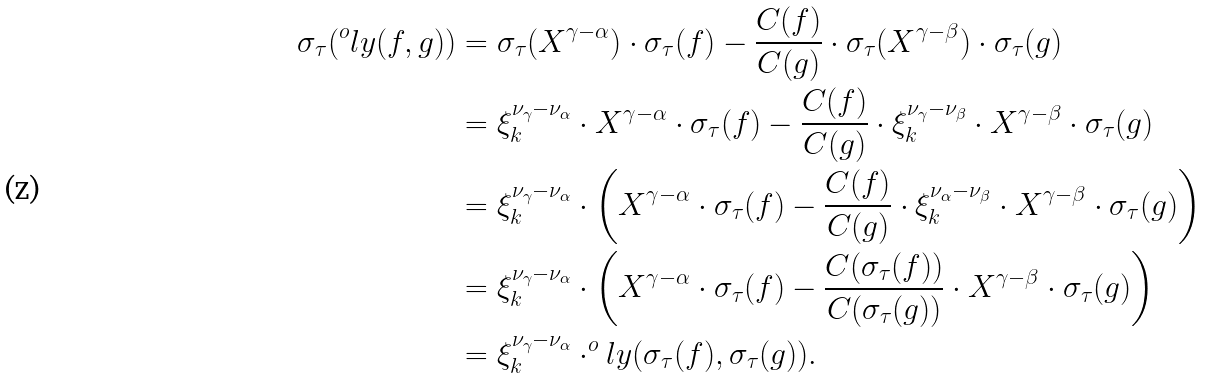<formula> <loc_0><loc_0><loc_500><loc_500>\sigma _ { \tau } ( ^ { o } l y ( f , g ) ) & = \sigma _ { \tau } ( X ^ { \gamma - \alpha } ) \cdot \sigma _ { \tau } ( f ) - \frac { \L C ( f ) } { \L C ( g ) } \cdot \sigma _ { \tau } ( X ^ { \gamma - \beta } ) \cdot \sigma _ { \tau } ( g ) \\ & = \xi _ { k } ^ { \nu _ { \gamma } - \nu _ { \alpha } } \cdot X ^ { \gamma - \alpha } \cdot \sigma _ { \tau } ( f ) - \frac { \L C ( f ) } { \L C ( g ) } \cdot \xi _ { k } ^ { \nu _ { \gamma } - \nu _ { \beta } } \cdot X ^ { \gamma - \beta } \cdot \sigma _ { \tau } ( g ) \\ & = \xi _ { k } ^ { \nu _ { \gamma } - \nu _ { \alpha } } \cdot \left ( X ^ { \gamma - \alpha } \cdot \sigma _ { \tau } ( f ) - \frac { \L C ( f ) } { \L C ( g ) } \cdot \xi _ { k } ^ { \nu _ { \alpha } - \nu _ { \beta } } \cdot X ^ { \gamma - \beta } \cdot \sigma _ { \tau } ( g ) \right ) \\ & = \xi _ { k } ^ { \nu _ { \gamma } - \nu _ { \alpha } } \cdot \left ( X ^ { \gamma - \alpha } \cdot \sigma _ { \tau } ( f ) - \frac { \L C ( \sigma _ { \tau } ( f ) ) } { \L C ( \sigma _ { \tau } ( g ) ) } \cdot X ^ { \gamma - \beta } \cdot \sigma _ { \tau } ( g ) \right ) \\ & = \xi _ { k } ^ { \nu _ { \gamma } - \nu _ { \alpha } } \cdot ^ { o } l y ( \sigma _ { \tau } ( f ) , \sigma _ { \tau } ( g ) ) .</formula> 